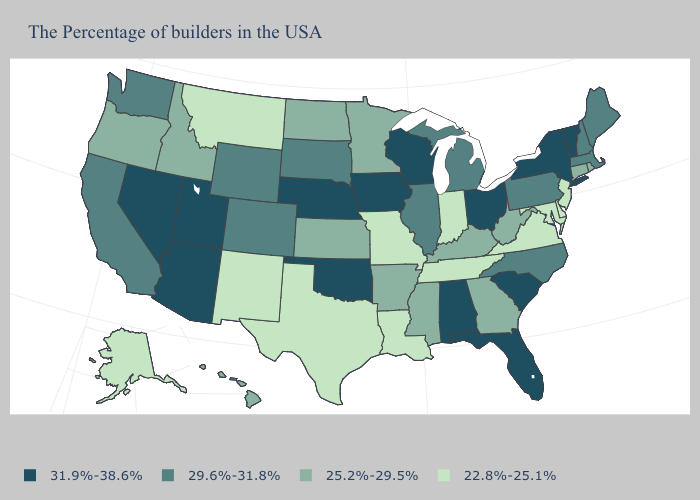What is the value of Florida?
Write a very short answer. 31.9%-38.6%. Which states have the highest value in the USA?
Answer briefly. Vermont, New York, South Carolina, Ohio, Florida, Alabama, Wisconsin, Iowa, Nebraska, Oklahoma, Utah, Arizona, Nevada. Which states have the lowest value in the South?
Give a very brief answer. Delaware, Maryland, Virginia, Tennessee, Louisiana, Texas. Name the states that have a value in the range 22.8%-25.1%?
Answer briefly. New Jersey, Delaware, Maryland, Virginia, Indiana, Tennessee, Louisiana, Missouri, Texas, New Mexico, Montana, Alaska. What is the value of Rhode Island?
Keep it brief. 25.2%-29.5%. What is the value of Illinois?
Write a very short answer. 29.6%-31.8%. Name the states that have a value in the range 31.9%-38.6%?
Quick response, please. Vermont, New York, South Carolina, Ohio, Florida, Alabama, Wisconsin, Iowa, Nebraska, Oklahoma, Utah, Arizona, Nevada. Name the states that have a value in the range 25.2%-29.5%?
Give a very brief answer. Rhode Island, Connecticut, West Virginia, Georgia, Kentucky, Mississippi, Arkansas, Minnesota, Kansas, North Dakota, Idaho, Oregon, Hawaii. What is the value of Maine?
Answer briefly. 29.6%-31.8%. Does Hawaii have the lowest value in the West?
Write a very short answer. No. Name the states that have a value in the range 22.8%-25.1%?
Give a very brief answer. New Jersey, Delaware, Maryland, Virginia, Indiana, Tennessee, Louisiana, Missouri, Texas, New Mexico, Montana, Alaska. Does Maine have the highest value in the Northeast?
Write a very short answer. No. Does Connecticut have the lowest value in the USA?
Give a very brief answer. No. What is the lowest value in states that border South Carolina?
Give a very brief answer. 25.2%-29.5%. Is the legend a continuous bar?
Answer briefly. No. 